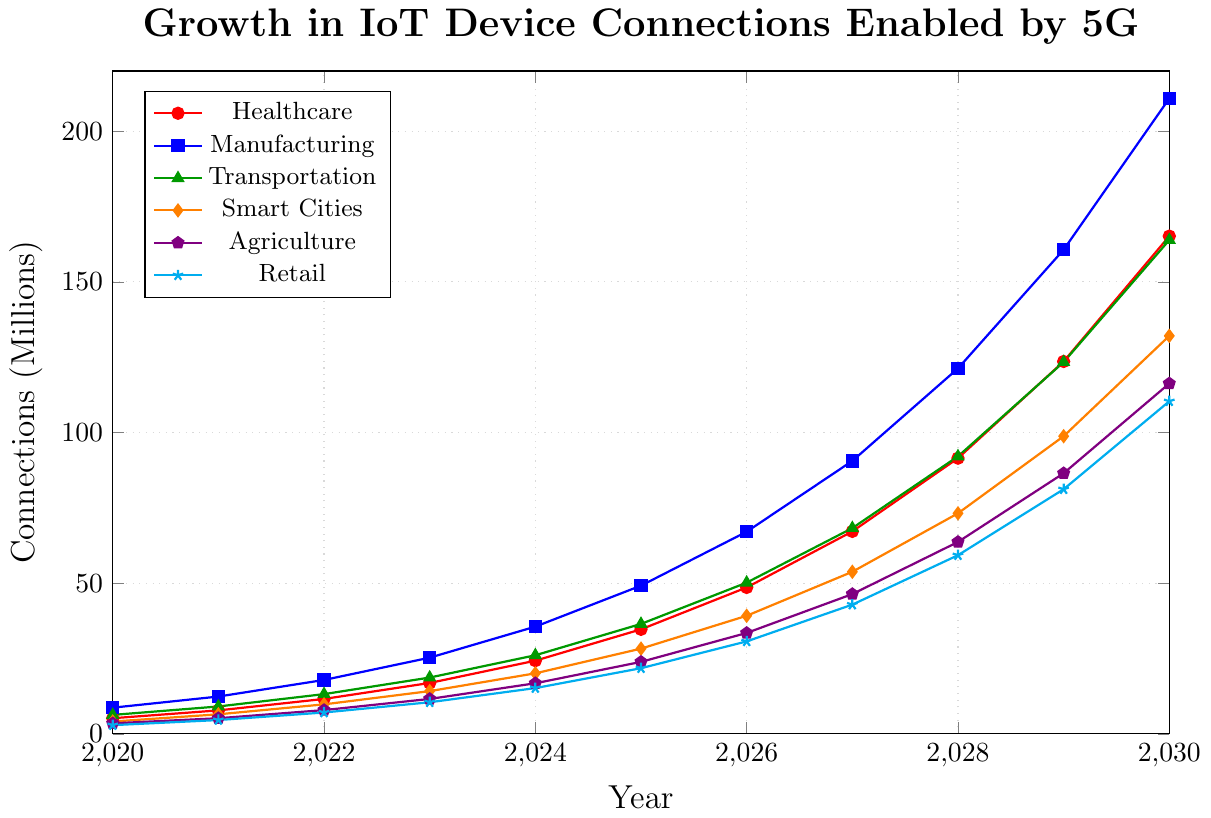What industry has the highest number of IoT device connections projected in 2030? To determine the industry with the highest number of IoT device connections in 2030, compare the values for each industry from the chart. Manufacturing has the highest projection with 210.9 million connections.
Answer: Manufacturing How many more IoT device connections are projected for Healthcare in 2029 compared to Agriculture in 2026? Find the number of connections for Healthcare in 2029 (123.6 million) and for Agriculture in 2026 (33.5 million). Subtract the latter from the former: 123.6 - 33.5 = 90.1 million.
Answer: 90.1 million Which year shows the largest increase in IoT device connections for the Transportation industry? Calculate the year-to-year increase for each year for the Transportation industry, noting the largest difference: The largest increase is from 2029 to 2030 with a difference of 40.5 million (163.9 - 123.4).
Answer: 2029 to 2030 What is the average number of IoT device connections for Smart Cities from 2025 to 2030? Calculate the average by summing the connections from 2025 to 2030 and dividing by the number of years: (28.3 + 39.2 + 53.8 + 73.2 + 98.8 + 132.1) / 6 = 70.9 million.
Answer: 70.9 million Which industry shows the smallest projected growth between 2028 and 2030? Assess the increase in connections for each industry between 2028 and 2030 and find the smallest increase. Retail shows the smallest growth with an increase of 51.1 million (110.4 - 59.3).
Answer: Retail How many total IoT device connections are projected for all industries combined in 2025? Sum the number of projected device connections for each industry in 2025: 34.7 + 49.2 + 36.5 + 28.3 + 23.9 + 21.8 = 194.4 million.
Answer: 194.4 million In which year does Agriculture surpass 50 million connections? Find the first year where Agriculture's connections are over 50 million by examining the chart. This happens in 2027 with 63.7 million connections.
Answer: 2027 